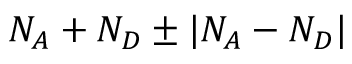<formula> <loc_0><loc_0><loc_500><loc_500>N _ { A } + N _ { D } \pm | N _ { A } - N _ { D } |</formula> 